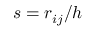Convert formula to latex. <formula><loc_0><loc_0><loc_500><loc_500>s = { r _ { i j } } { / h }</formula> 